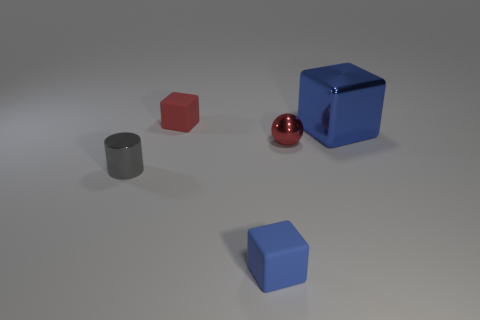There is a small object that is on the right side of the blue cube left of the big metallic block that is to the right of the tiny sphere; what is it made of?
Keep it short and to the point. Metal. What number of other things are the same size as the blue rubber thing?
Your response must be concise. 3. Is the big metal thing the same color as the tiny shiny sphere?
Give a very brief answer. No. What number of matte cubes are in front of the cube right of the blue matte object in front of the small red matte block?
Provide a succinct answer. 1. The red thing that is right of the red rubber thing that is behind the blue shiny object is made of what material?
Give a very brief answer. Metal. Is there a tiny purple metallic object of the same shape as the tiny gray object?
Offer a very short reply. No. The shiny sphere that is the same size as the gray metallic thing is what color?
Ensure brevity in your answer.  Red. What number of objects are either blue things in front of the big metallic block or red objects that are left of the tiny blue thing?
Your answer should be compact. 2. What number of things are small gray metallic cubes or metal blocks?
Provide a short and direct response. 1. How big is the cube that is behind the gray cylinder and in front of the red cube?
Your response must be concise. Large. 